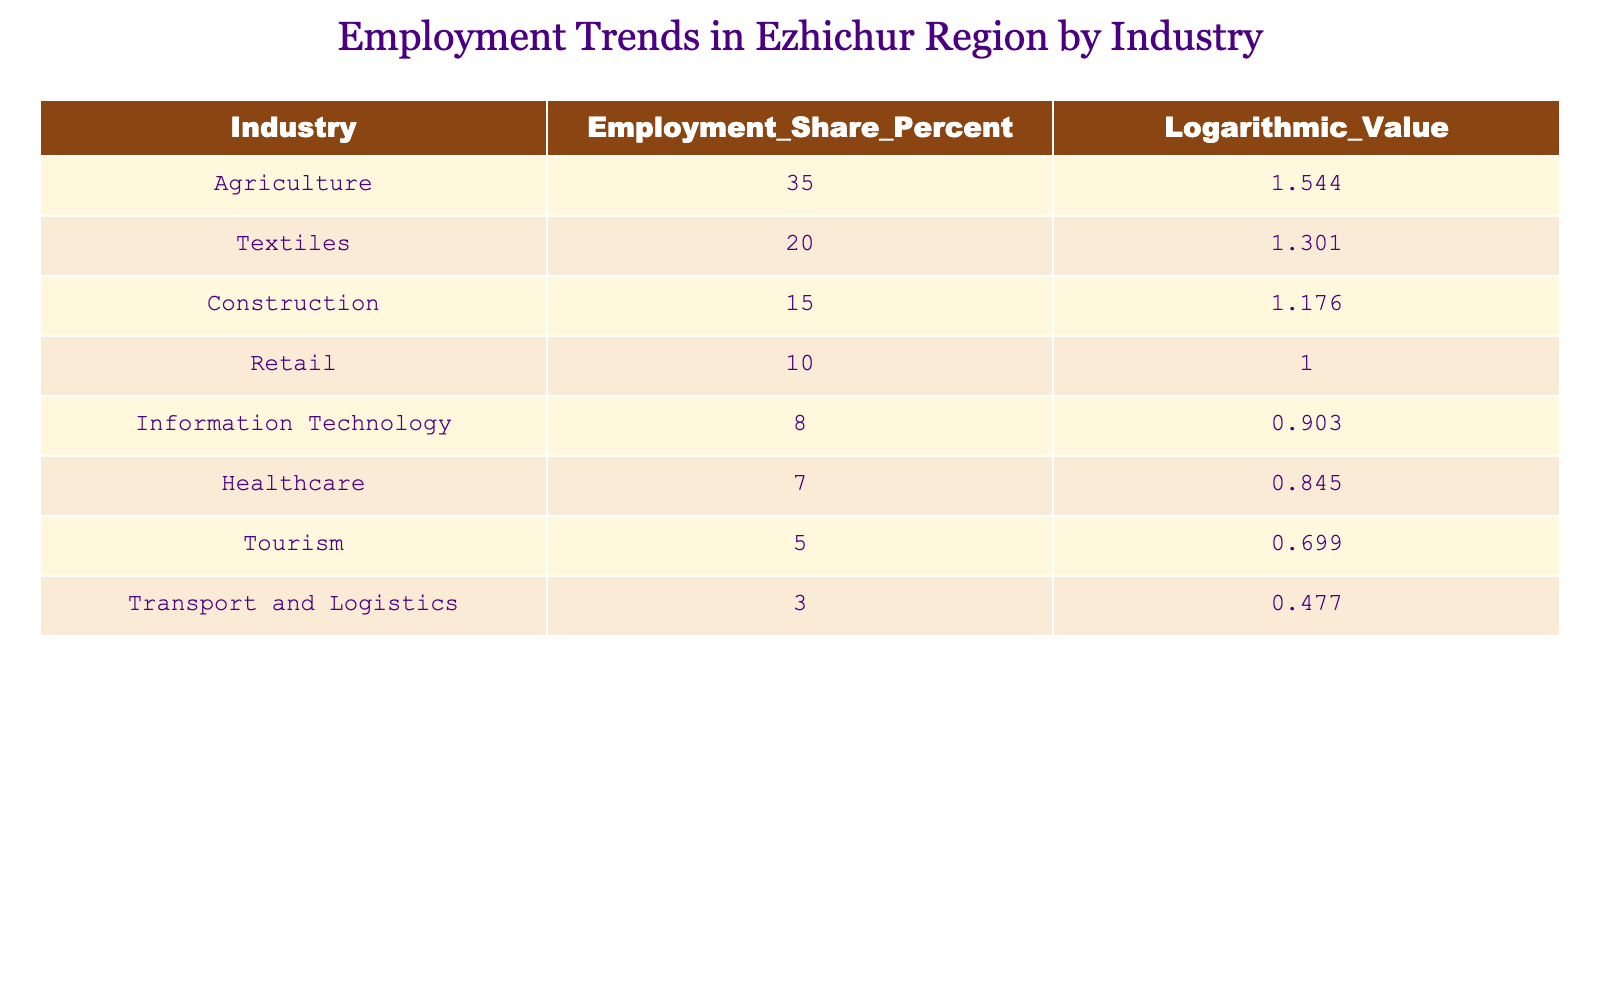What is the employment share percentage for the Agriculture industry? The table lists the Agriculture industry's employment share percentage as shown. By checking the corresponding value in the "Employment_Share_Percent" column, we can see that it is 35 percent.
Answer: 35 Which industry has the lowest employment share percentage? Looking through the table, we see that the Transport and Logistics industry has the lowest share at 3 percent. This is confirmed by comparing all the values in the "Employment_Share_Percent" column.
Answer: 3 What is the total employment share percentage for Textile, Construction, and Retail industries combined? To find the total, we add the employment share percentages of these three industries: 20 (Textiles) + 15 (Construction) + 10 (Retail) = 45. Thus, the combined share is 45 percent.
Answer: 45 Is the employment share percentage for Healthcare more than 5 percent? Checking the "Employment_Share_Percent" for the Healthcare industry, we see it has 7 percent. Since 7 is greater than 5, the answer is yes.
Answer: Yes What is the difference in logarithmic values between the Agriculture and Tourism industries? To find the difference, we subtract the logarithmic value of Tourism (0.699) from that of Agriculture (1.544): 1.544 - 0.699 = 0.845. This indicates a significant difference in their logarithmic values.
Answer: 0.845 Which industries have an employment share percentage greater than 10 percent? By reviewing the "Employment_Share_Percent" column, we see that Agriculture (35), Textiles (20), and Construction (15) all have values greater than 10 percent. Therefore, there are three industries that meet this criterion: Agriculture, Textiles, and Construction.
Answer: Agriculture, Textiles, and Construction What is the average employment share percentage across all industries listed in the table? We add up all the employment shares: 35 + 20 + 15 + 10 + 8 + 7 + 5 + 3 = 103. There are 8 industries, so we divide the sum by 8: 103 / 8 = 12.875, which gives us the average percentage.
Answer: 12.875 Is it true that the Information Technology industry has a logarithmic value of less than 0.9? The logarithmic value for Information Technology is 0.903, which is not less than 0.9. Thus, the statement is false.
Answer: No What is the logarithmic value for the industry with the highest employment share? By scanning the table, we find that Agriculture has the highest employment share percent at 35, and its logarithmic value is 1.544. Therefore, this is the logarithmic value for the highest employment share industry.
Answer: 1.544 